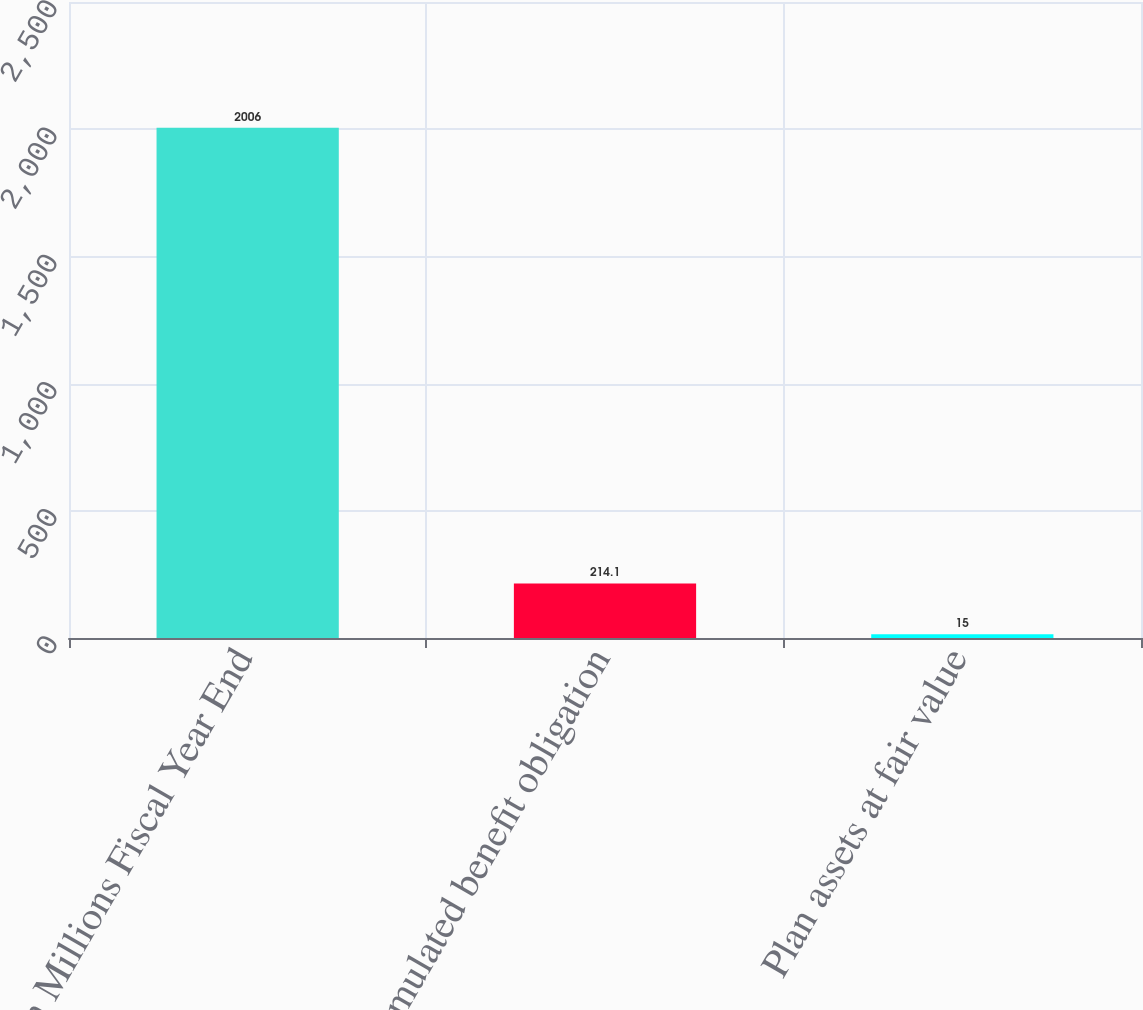Convert chart to OTSL. <chart><loc_0><loc_0><loc_500><loc_500><bar_chart><fcel>In Millions Fiscal Year End<fcel>Accumulated benefit obligation<fcel>Plan assets at fair value<nl><fcel>2006<fcel>214.1<fcel>15<nl></chart> 